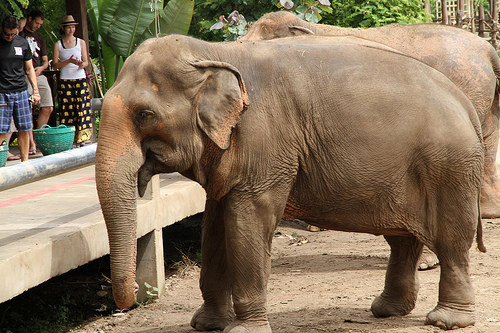What color does the basket have? The basket is green. 